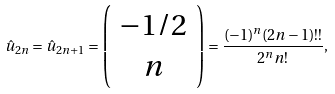Convert formula to latex. <formula><loc_0><loc_0><loc_500><loc_500>\hat { u } _ { 2 n } = \hat { u } _ { 2 n + 1 } = \left ( \begin{array} { c } { - 1 / 2 } \\ { n } \end{array} \right ) = { \frac { ( - 1 ) ^ { n } ( 2 n - 1 ) ! ! } { 2 ^ { n } n ! } } ,</formula> 